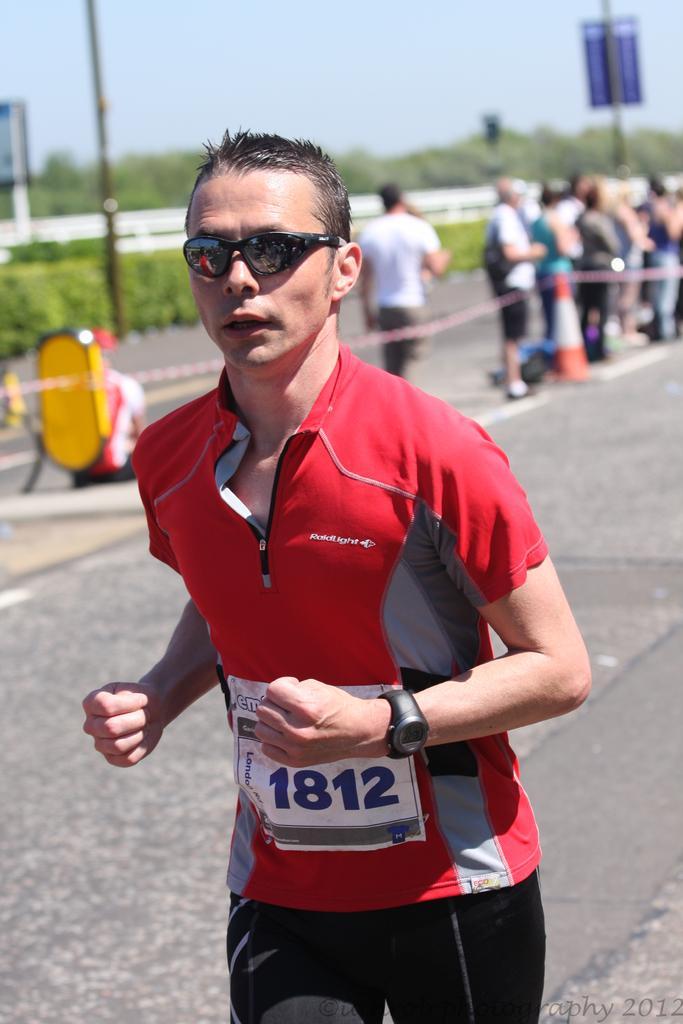How would you summarize this image in a sentence or two? A man is running on the road, he is wearing goggles and red and black costume behind the men on the left side there are a group of people standing behind a rope and in the background there are a lot of trees. 